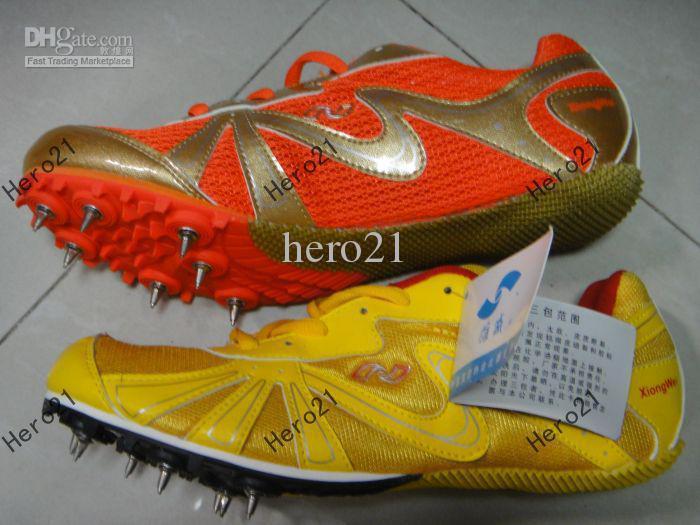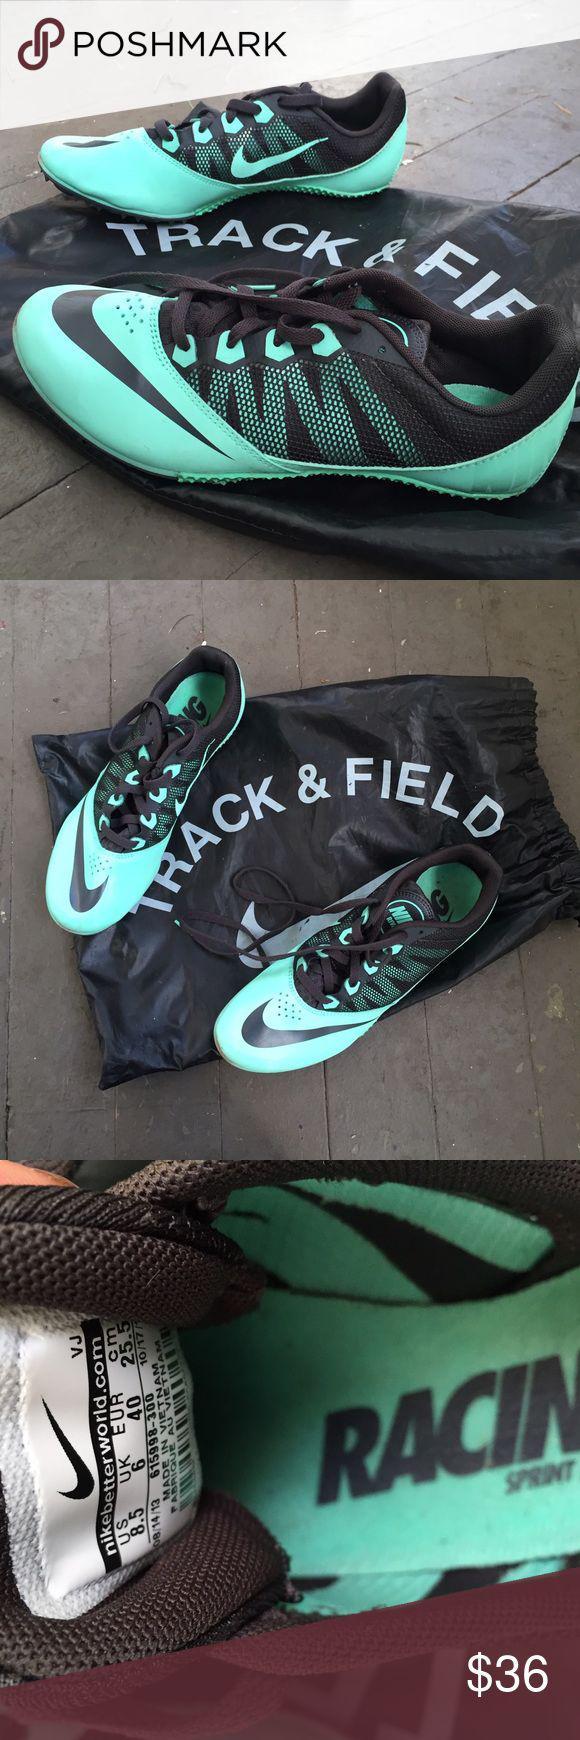The first image is the image on the left, the second image is the image on the right. For the images shown, is this caption "There are at least 8 shoes." true? Answer yes or no. No. 